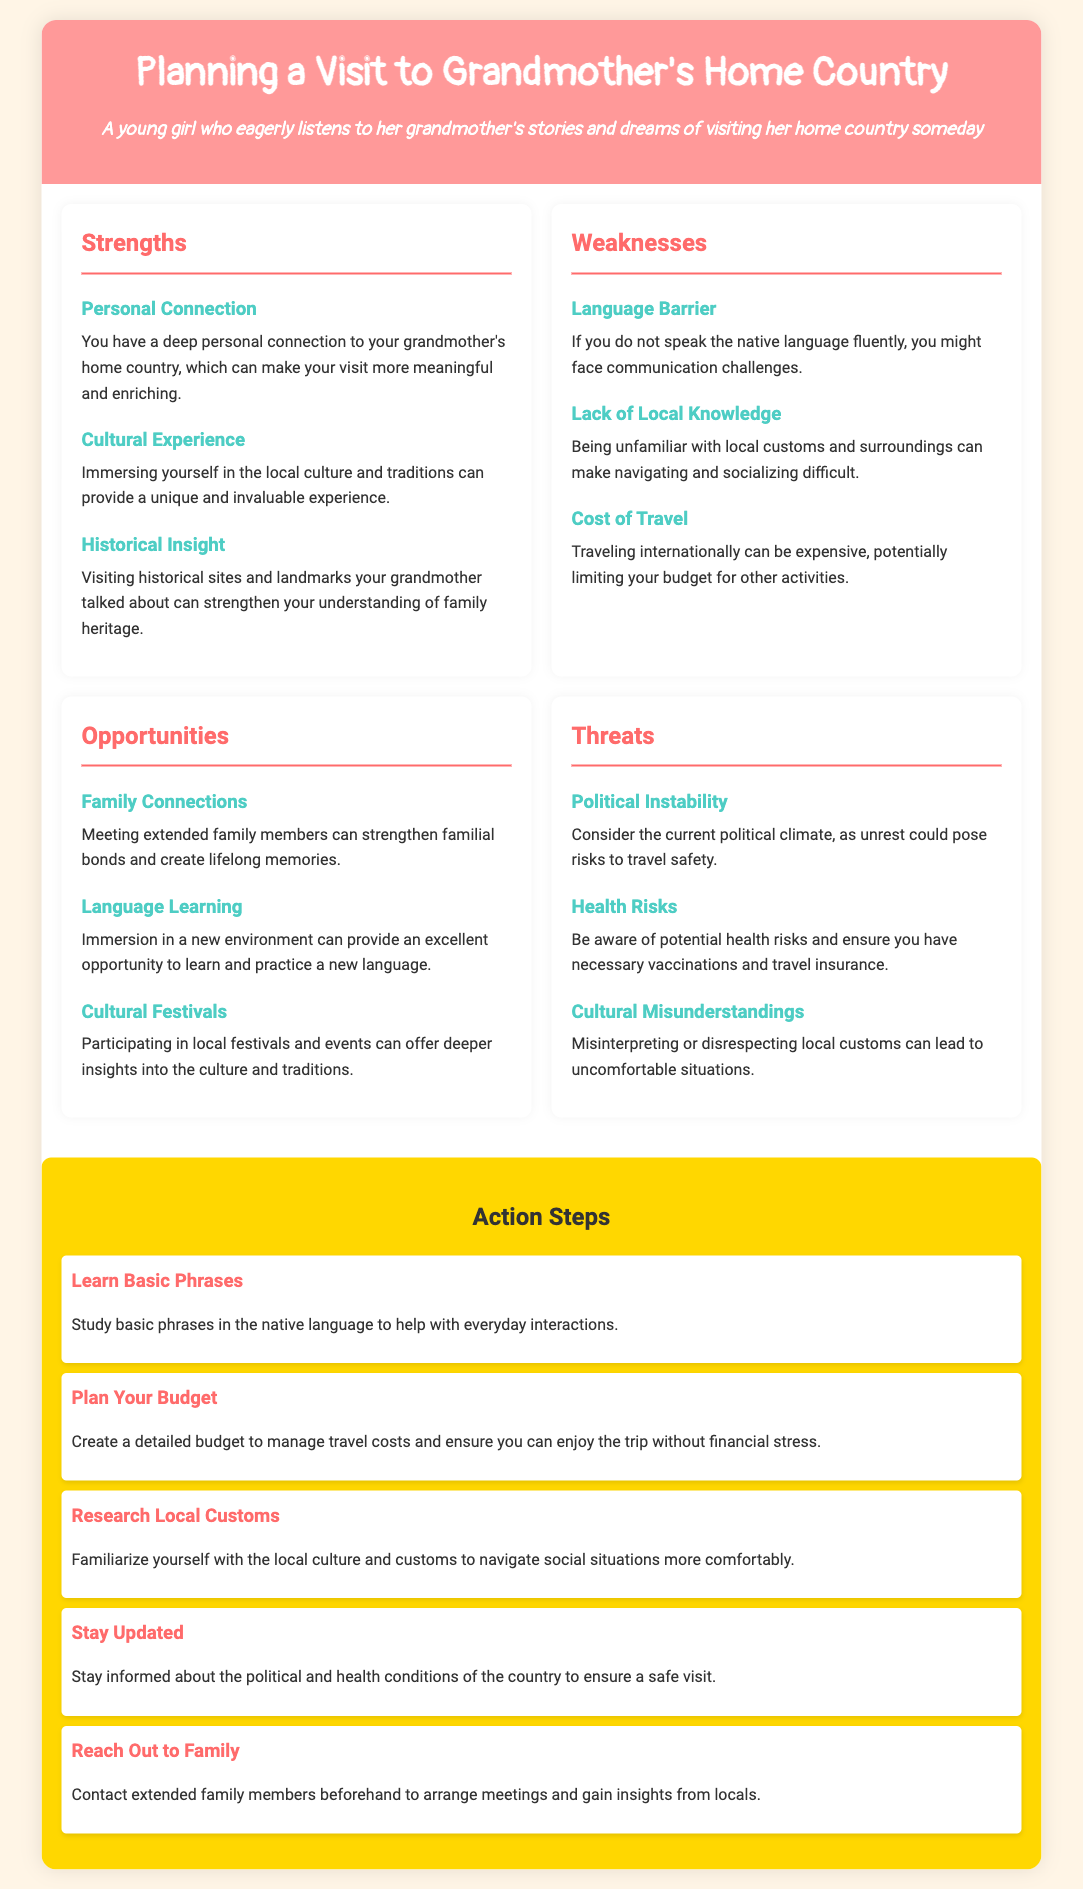What are the strengths in the SWOT analysis? The strengths section lists three items that include Personal Connection, Cultural Experience, and Historical Insight.
Answer: Personal Connection, Cultural Experience, Historical Insight What is a weakness mentioned regarding language? The weakness section discusses challenges related to communication, specifically highlighting the language barrier.
Answer: Language Barrier How many action steps are provided in the document? The action steps section contains a list outlining five specific actions to prepare for the visit.
Answer: Five What opportunity involves family members? In the opportunities section, one item discusses strengthening family bonds through meeting extended family members.
Answer: Family Connections What threat relates to health safety? The threats section notes the importance of being aware of health risks and vaccinations required for travel.
Answer: Health Risks Which cultural aspect can provide insights according to the opportunities? One opportunity discussed emphasizes participating in local festivals and events as a way to engage with the culture.
Answer: Cultural Festivals What basic preparation is suggested in the action steps? The action steps mention learning basic phrases in the native language as an important first step.
Answer: Learn Basic Phrases 